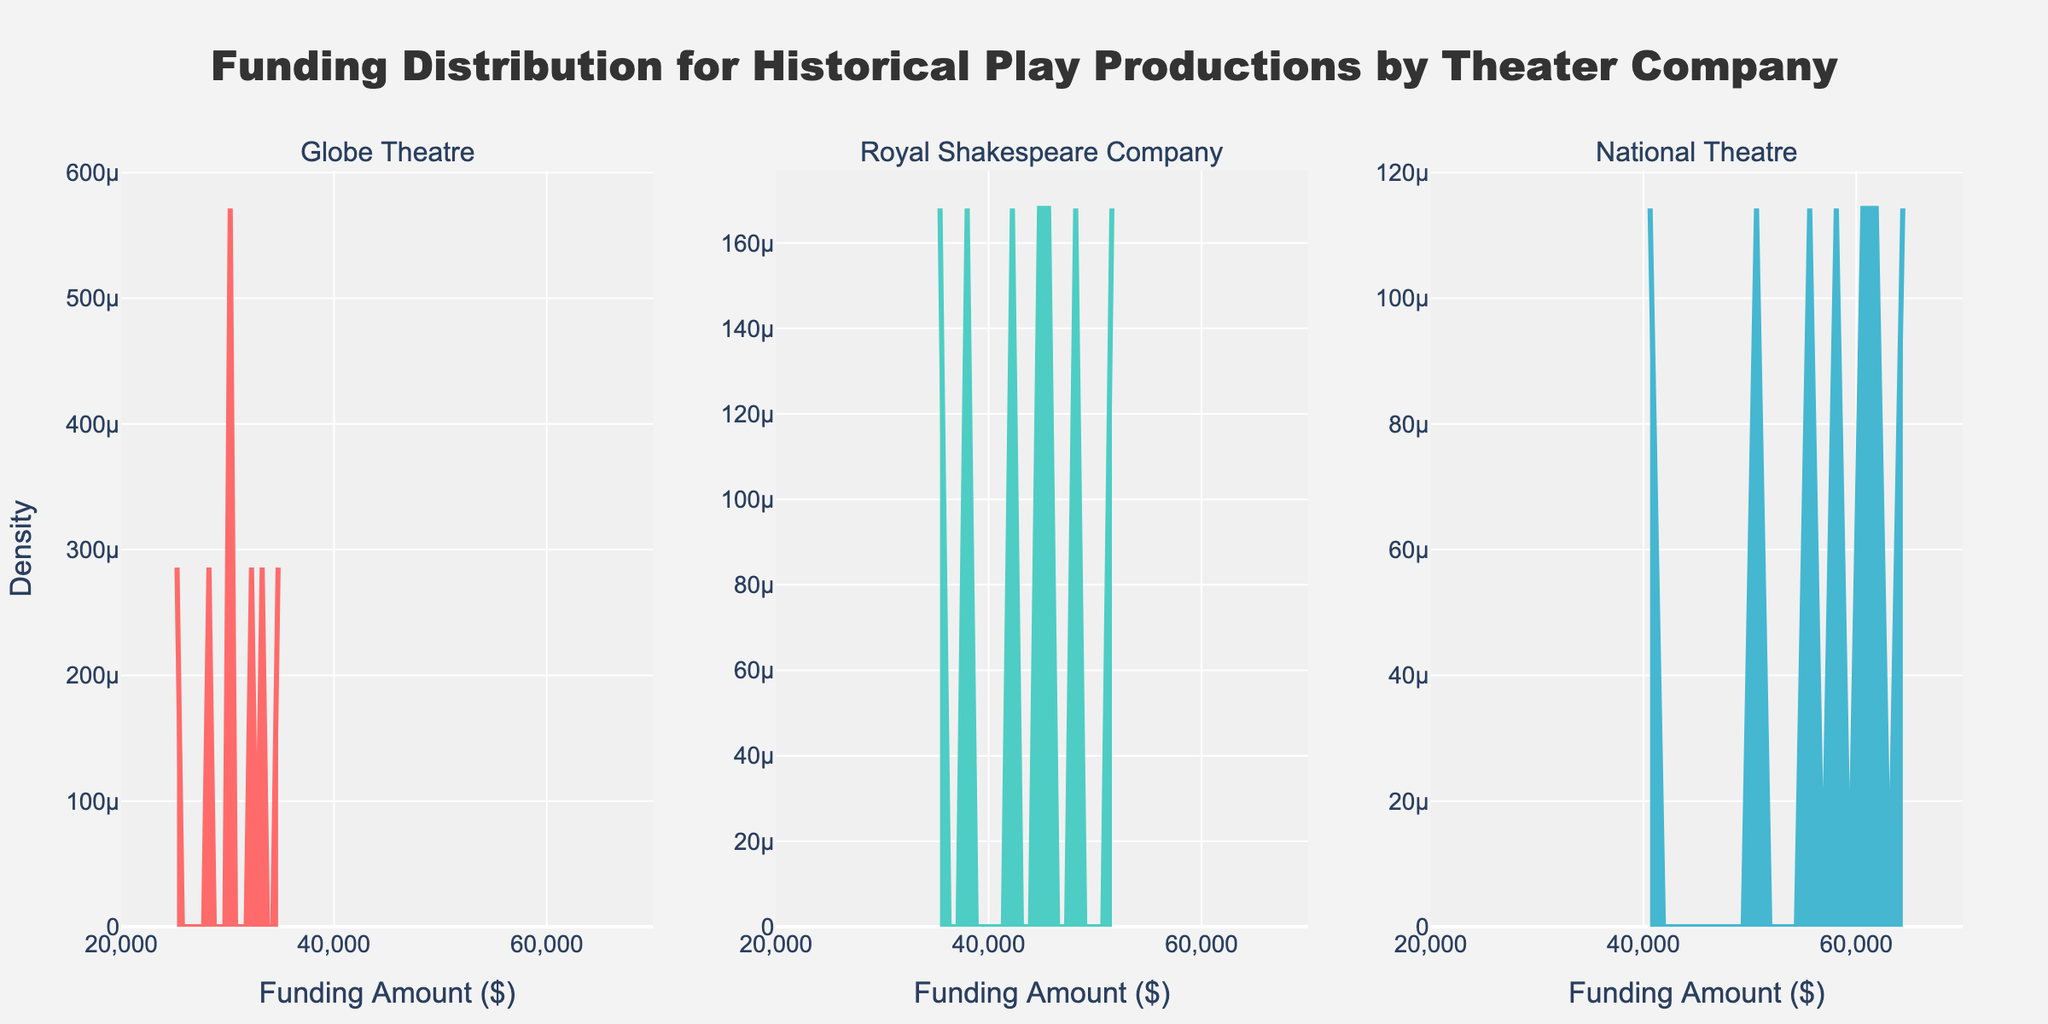How many theater companies are shown in the figure? The subplot titles indicate that the figure contains density plots for Globe Theatre, Royal Shakespeare Company, and National Theatre. There are three unique companies mentioned.
Answer: 3 Which company received the highest single funding amount in the data? To determine the highest single funding amount, we need to look at the peaks of the density plots. The National Theatre's density plot shows a peak around the highest funding amount, which aligns with their highest funding amount of $65,000.
Answer: National Theatre What is the range of funding amounts presented in the figure? The x-axes of the subplots indicate the funding amount ranges. The range on the x-axes uniformly spans from $20,000 to $70,000.
Answer: $20,000 to $70,000 Which company has the most variation in funding amounts received, based on the density plots? To judge the variation, we look at the spread and shape of the density plots. The National Theatre's density plot has peaks that are more spread out compared to others, suggesting more variation.
Answer: National Theatre What is the approximate funding amount for the Globe Theatre that corresponds to the highest density? The peak of the density plot for the Globe Theatre indicates the most frequent funding amount. This peak is around $30,000.
Answer: $30,000 Between the Royal Shakespeare Company and the Globe Theatre, which company has the higher general density peak? By comparing the height of the density peaks, the Royal Shakespeare Company's peak appears higher than the peak of the same width in the Globe Theatre's plot.
Answer: Royal Shakespeare Company Are there any funding amounts that show no density for any of the companies? The regions at the extreme ends of the x-axis, closer to $70,000 and below $25,000, show minimal or no density in the plots, indicating these funding amounts are uncommon or absent in the data.
Answer: Yes How does the funding distribution of National Theatre compare to Globe Theatre? National Theatre's distribution shows several peaks and a wider spread of funding amounts, indicating a more varied funding distribution compared to the narrower and more concentrated distribution of the Globe Theatre.
Answer: More varied for National Theatre If you sum the highest density points of all three companies, what would be the approximate total funding amount? The highest density points are at approximately $30,000 for Globe Theatre, $38,000 for Royal Shakespeare Company, and $60,000 for National Theatre. Summing these amounts gives $30,000 + $38,000 + $60,000 = $128,000.
Answer: $128,000 